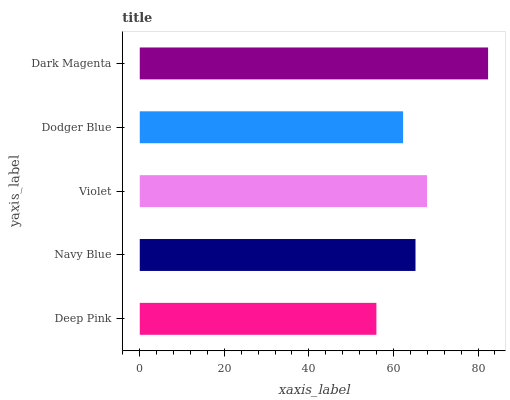Is Deep Pink the minimum?
Answer yes or no. Yes. Is Dark Magenta the maximum?
Answer yes or no. Yes. Is Navy Blue the minimum?
Answer yes or no. No. Is Navy Blue the maximum?
Answer yes or no. No. Is Navy Blue greater than Deep Pink?
Answer yes or no. Yes. Is Deep Pink less than Navy Blue?
Answer yes or no. Yes. Is Deep Pink greater than Navy Blue?
Answer yes or no. No. Is Navy Blue less than Deep Pink?
Answer yes or no. No. Is Navy Blue the high median?
Answer yes or no. Yes. Is Navy Blue the low median?
Answer yes or no. Yes. Is Deep Pink the high median?
Answer yes or no. No. Is Dodger Blue the low median?
Answer yes or no. No. 